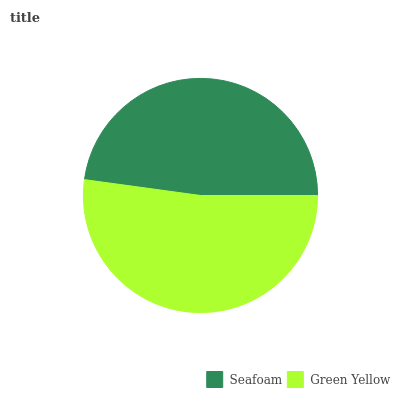Is Seafoam the minimum?
Answer yes or no. Yes. Is Green Yellow the maximum?
Answer yes or no. Yes. Is Green Yellow the minimum?
Answer yes or no. No. Is Green Yellow greater than Seafoam?
Answer yes or no. Yes. Is Seafoam less than Green Yellow?
Answer yes or no. Yes. Is Seafoam greater than Green Yellow?
Answer yes or no. No. Is Green Yellow less than Seafoam?
Answer yes or no. No. Is Green Yellow the high median?
Answer yes or no. Yes. Is Seafoam the low median?
Answer yes or no. Yes. Is Seafoam the high median?
Answer yes or no. No. Is Green Yellow the low median?
Answer yes or no. No. 